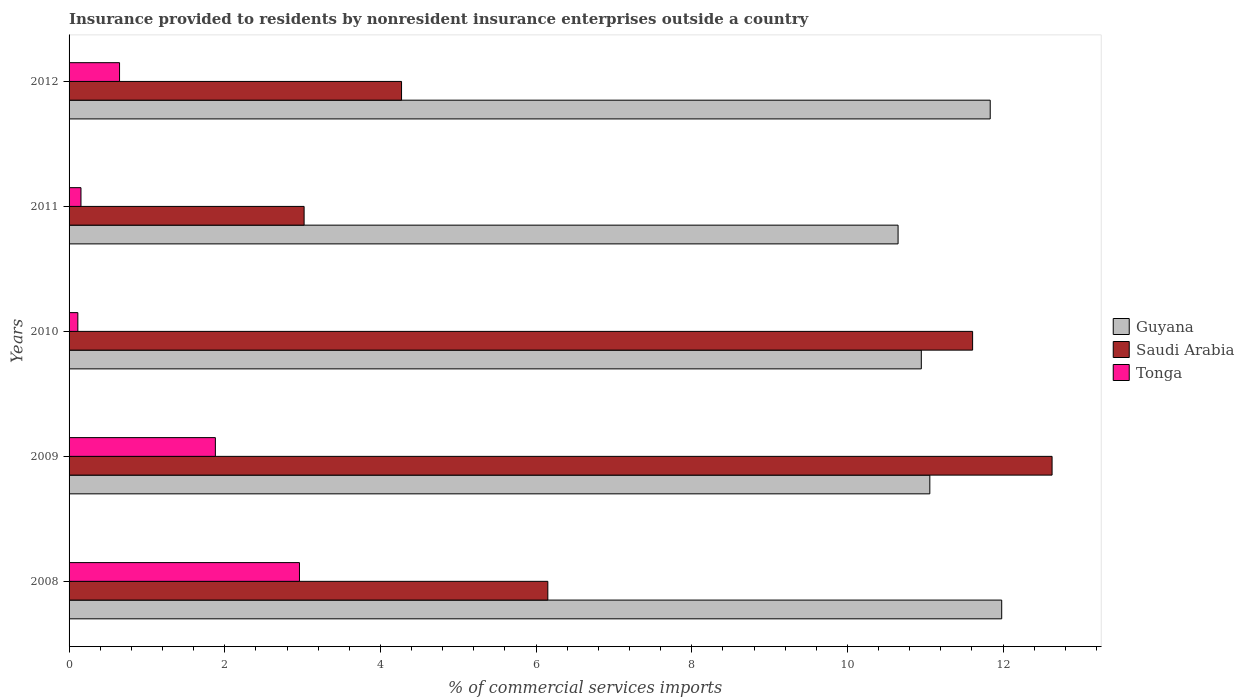How many bars are there on the 4th tick from the top?
Your answer should be very brief. 3. What is the label of the 1st group of bars from the top?
Give a very brief answer. 2012. In how many cases, is the number of bars for a given year not equal to the number of legend labels?
Offer a terse response. 0. What is the Insurance provided to residents in Tonga in 2008?
Make the answer very short. 2.96. Across all years, what is the maximum Insurance provided to residents in Tonga?
Keep it short and to the point. 2.96. Across all years, what is the minimum Insurance provided to residents in Tonga?
Ensure brevity in your answer.  0.11. In which year was the Insurance provided to residents in Saudi Arabia minimum?
Provide a short and direct response. 2011. What is the total Insurance provided to residents in Tonga in the graph?
Give a very brief answer. 5.75. What is the difference between the Insurance provided to residents in Saudi Arabia in 2010 and that in 2011?
Provide a succinct answer. 8.59. What is the difference between the Insurance provided to residents in Tonga in 2010 and the Insurance provided to residents in Saudi Arabia in 2009?
Make the answer very short. -12.52. What is the average Insurance provided to residents in Guyana per year?
Your answer should be very brief. 11.3. In the year 2008, what is the difference between the Insurance provided to residents in Guyana and Insurance provided to residents in Tonga?
Ensure brevity in your answer.  9.02. In how many years, is the Insurance provided to residents in Tonga greater than 10 %?
Offer a very short reply. 0. What is the ratio of the Insurance provided to residents in Saudi Arabia in 2008 to that in 2009?
Provide a succinct answer. 0.49. Is the Insurance provided to residents in Guyana in 2011 less than that in 2012?
Offer a very short reply. Yes. What is the difference between the highest and the second highest Insurance provided to residents in Saudi Arabia?
Ensure brevity in your answer.  1.02. What is the difference between the highest and the lowest Insurance provided to residents in Guyana?
Make the answer very short. 1.33. What does the 3rd bar from the top in 2009 represents?
Your answer should be compact. Guyana. What does the 1st bar from the bottom in 2010 represents?
Your answer should be compact. Guyana. Are all the bars in the graph horizontal?
Ensure brevity in your answer.  Yes. What is the difference between two consecutive major ticks on the X-axis?
Your answer should be very brief. 2. Does the graph contain any zero values?
Offer a very short reply. No. Where does the legend appear in the graph?
Offer a terse response. Center right. How many legend labels are there?
Provide a succinct answer. 3. How are the legend labels stacked?
Offer a very short reply. Vertical. What is the title of the graph?
Your response must be concise. Insurance provided to residents by nonresident insurance enterprises outside a country. What is the label or title of the X-axis?
Ensure brevity in your answer.  % of commercial services imports. What is the % of commercial services imports of Guyana in 2008?
Your answer should be compact. 11.98. What is the % of commercial services imports of Saudi Arabia in 2008?
Make the answer very short. 6.15. What is the % of commercial services imports in Tonga in 2008?
Make the answer very short. 2.96. What is the % of commercial services imports of Guyana in 2009?
Offer a terse response. 11.06. What is the % of commercial services imports of Saudi Arabia in 2009?
Offer a terse response. 12.63. What is the % of commercial services imports in Tonga in 2009?
Ensure brevity in your answer.  1.88. What is the % of commercial services imports in Guyana in 2010?
Offer a terse response. 10.95. What is the % of commercial services imports of Saudi Arabia in 2010?
Ensure brevity in your answer.  11.61. What is the % of commercial services imports in Tonga in 2010?
Your answer should be compact. 0.11. What is the % of commercial services imports in Guyana in 2011?
Provide a short and direct response. 10.65. What is the % of commercial services imports of Saudi Arabia in 2011?
Make the answer very short. 3.02. What is the % of commercial services imports in Tonga in 2011?
Make the answer very short. 0.15. What is the % of commercial services imports of Guyana in 2012?
Your answer should be compact. 11.83. What is the % of commercial services imports in Saudi Arabia in 2012?
Provide a short and direct response. 4.27. What is the % of commercial services imports in Tonga in 2012?
Make the answer very short. 0.65. Across all years, what is the maximum % of commercial services imports of Guyana?
Your answer should be very brief. 11.98. Across all years, what is the maximum % of commercial services imports in Saudi Arabia?
Your answer should be very brief. 12.63. Across all years, what is the maximum % of commercial services imports in Tonga?
Offer a terse response. 2.96. Across all years, what is the minimum % of commercial services imports in Guyana?
Provide a short and direct response. 10.65. Across all years, what is the minimum % of commercial services imports of Saudi Arabia?
Provide a succinct answer. 3.02. Across all years, what is the minimum % of commercial services imports in Tonga?
Your response must be concise. 0.11. What is the total % of commercial services imports in Guyana in the graph?
Your answer should be very brief. 56.48. What is the total % of commercial services imports of Saudi Arabia in the graph?
Keep it short and to the point. 37.68. What is the total % of commercial services imports of Tonga in the graph?
Make the answer very short. 5.75. What is the difference between the % of commercial services imports of Guyana in 2008 and that in 2009?
Ensure brevity in your answer.  0.92. What is the difference between the % of commercial services imports of Saudi Arabia in 2008 and that in 2009?
Keep it short and to the point. -6.48. What is the difference between the % of commercial services imports of Tonga in 2008 and that in 2009?
Give a very brief answer. 1.08. What is the difference between the % of commercial services imports of Guyana in 2008 and that in 2010?
Your response must be concise. 1.03. What is the difference between the % of commercial services imports of Saudi Arabia in 2008 and that in 2010?
Give a very brief answer. -5.46. What is the difference between the % of commercial services imports of Tonga in 2008 and that in 2010?
Keep it short and to the point. 2.85. What is the difference between the % of commercial services imports of Guyana in 2008 and that in 2011?
Your response must be concise. 1.33. What is the difference between the % of commercial services imports in Saudi Arabia in 2008 and that in 2011?
Your response must be concise. 3.13. What is the difference between the % of commercial services imports of Tonga in 2008 and that in 2011?
Keep it short and to the point. 2.81. What is the difference between the % of commercial services imports in Guyana in 2008 and that in 2012?
Provide a short and direct response. 0.15. What is the difference between the % of commercial services imports in Saudi Arabia in 2008 and that in 2012?
Your answer should be compact. 1.88. What is the difference between the % of commercial services imports in Tonga in 2008 and that in 2012?
Keep it short and to the point. 2.31. What is the difference between the % of commercial services imports of Guyana in 2009 and that in 2010?
Your answer should be compact. 0.11. What is the difference between the % of commercial services imports in Saudi Arabia in 2009 and that in 2010?
Keep it short and to the point. 1.02. What is the difference between the % of commercial services imports of Tonga in 2009 and that in 2010?
Provide a succinct answer. 1.77. What is the difference between the % of commercial services imports in Guyana in 2009 and that in 2011?
Make the answer very short. 0.41. What is the difference between the % of commercial services imports of Saudi Arabia in 2009 and that in 2011?
Your answer should be very brief. 9.61. What is the difference between the % of commercial services imports in Tonga in 2009 and that in 2011?
Provide a succinct answer. 1.73. What is the difference between the % of commercial services imports in Guyana in 2009 and that in 2012?
Offer a very short reply. -0.78. What is the difference between the % of commercial services imports in Saudi Arabia in 2009 and that in 2012?
Your answer should be very brief. 8.36. What is the difference between the % of commercial services imports of Tonga in 2009 and that in 2012?
Provide a short and direct response. 1.23. What is the difference between the % of commercial services imports of Guyana in 2010 and that in 2011?
Offer a very short reply. 0.3. What is the difference between the % of commercial services imports of Saudi Arabia in 2010 and that in 2011?
Provide a succinct answer. 8.59. What is the difference between the % of commercial services imports of Tonga in 2010 and that in 2011?
Give a very brief answer. -0.04. What is the difference between the % of commercial services imports of Guyana in 2010 and that in 2012?
Your response must be concise. -0.89. What is the difference between the % of commercial services imports of Saudi Arabia in 2010 and that in 2012?
Give a very brief answer. 7.34. What is the difference between the % of commercial services imports in Tonga in 2010 and that in 2012?
Your answer should be very brief. -0.54. What is the difference between the % of commercial services imports in Guyana in 2011 and that in 2012?
Offer a very short reply. -1.18. What is the difference between the % of commercial services imports in Saudi Arabia in 2011 and that in 2012?
Your response must be concise. -1.25. What is the difference between the % of commercial services imports in Tonga in 2011 and that in 2012?
Provide a short and direct response. -0.5. What is the difference between the % of commercial services imports of Guyana in 2008 and the % of commercial services imports of Saudi Arabia in 2009?
Your answer should be compact. -0.65. What is the difference between the % of commercial services imports of Guyana in 2008 and the % of commercial services imports of Tonga in 2009?
Offer a terse response. 10.1. What is the difference between the % of commercial services imports in Saudi Arabia in 2008 and the % of commercial services imports in Tonga in 2009?
Offer a very short reply. 4.27. What is the difference between the % of commercial services imports in Guyana in 2008 and the % of commercial services imports in Saudi Arabia in 2010?
Offer a terse response. 0.37. What is the difference between the % of commercial services imports of Guyana in 2008 and the % of commercial services imports of Tonga in 2010?
Provide a succinct answer. 11.87. What is the difference between the % of commercial services imports of Saudi Arabia in 2008 and the % of commercial services imports of Tonga in 2010?
Provide a short and direct response. 6.04. What is the difference between the % of commercial services imports of Guyana in 2008 and the % of commercial services imports of Saudi Arabia in 2011?
Provide a succinct answer. 8.96. What is the difference between the % of commercial services imports of Guyana in 2008 and the % of commercial services imports of Tonga in 2011?
Provide a short and direct response. 11.83. What is the difference between the % of commercial services imports of Saudi Arabia in 2008 and the % of commercial services imports of Tonga in 2011?
Your answer should be very brief. 6. What is the difference between the % of commercial services imports of Guyana in 2008 and the % of commercial services imports of Saudi Arabia in 2012?
Give a very brief answer. 7.71. What is the difference between the % of commercial services imports in Guyana in 2008 and the % of commercial services imports in Tonga in 2012?
Your answer should be very brief. 11.33. What is the difference between the % of commercial services imports of Saudi Arabia in 2008 and the % of commercial services imports of Tonga in 2012?
Ensure brevity in your answer.  5.5. What is the difference between the % of commercial services imports in Guyana in 2009 and the % of commercial services imports in Saudi Arabia in 2010?
Make the answer very short. -0.55. What is the difference between the % of commercial services imports in Guyana in 2009 and the % of commercial services imports in Tonga in 2010?
Your response must be concise. 10.95. What is the difference between the % of commercial services imports in Saudi Arabia in 2009 and the % of commercial services imports in Tonga in 2010?
Ensure brevity in your answer.  12.52. What is the difference between the % of commercial services imports in Guyana in 2009 and the % of commercial services imports in Saudi Arabia in 2011?
Your answer should be very brief. 8.04. What is the difference between the % of commercial services imports of Guyana in 2009 and the % of commercial services imports of Tonga in 2011?
Provide a short and direct response. 10.91. What is the difference between the % of commercial services imports in Saudi Arabia in 2009 and the % of commercial services imports in Tonga in 2011?
Ensure brevity in your answer.  12.48. What is the difference between the % of commercial services imports in Guyana in 2009 and the % of commercial services imports in Saudi Arabia in 2012?
Your answer should be compact. 6.79. What is the difference between the % of commercial services imports of Guyana in 2009 and the % of commercial services imports of Tonga in 2012?
Keep it short and to the point. 10.41. What is the difference between the % of commercial services imports in Saudi Arabia in 2009 and the % of commercial services imports in Tonga in 2012?
Provide a short and direct response. 11.98. What is the difference between the % of commercial services imports of Guyana in 2010 and the % of commercial services imports of Saudi Arabia in 2011?
Your answer should be very brief. 7.93. What is the difference between the % of commercial services imports of Guyana in 2010 and the % of commercial services imports of Tonga in 2011?
Your response must be concise. 10.8. What is the difference between the % of commercial services imports of Saudi Arabia in 2010 and the % of commercial services imports of Tonga in 2011?
Offer a terse response. 11.46. What is the difference between the % of commercial services imports of Guyana in 2010 and the % of commercial services imports of Saudi Arabia in 2012?
Your response must be concise. 6.68. What is the difference between the % of commercial services imports in Guyana in 2010 and the % of commercial services imports in Tonga in 2012?
Your answer should be very brief. 10.3. What is the difference between the % of commercial services imports of Saudi Arabia in 2010 and the % of commercial services imports of Tonga in 2012?
Keep it short and to the point. 10.96. What is the difference between the % of commercial services imports of Guyana in 2011 and the % of commercial services imports of Saudi Arabia in 2012?
Provide a succinct answer. 6.38. What is the difference between the % of commercial services imports in Guyana in 2011 and the % of commercial services imports in Tonga in 2012?
Provide a short and direct response. 10. What is the difference between the % of commercial services imports in Saudi Arabia in 2011 and the % of commercial services imports in Tonga in 2012?
Give a very brief answer. 2.37. What is the average % of commercial services imports in Guyana per year?
Provide a short and direct response. 11.3. What is the average % of commercial services imports of Saudi Arabia per year?
Keep it short and to the point. 7.54. What is the average % of commercial services imports of Tonga per year?
Your answer should be very brief. 1.15. In the year 2008, what is the difference between the % of commercial services imports of Guyana and % of commercial services imports of Saudi Arabia?
Your answer should be very brief. 5.83. In the year 2008, what is the difference between the % of commercial services imports of Guyana and % of commercial services imports of Tonga?
Provide a succinct answer. 9.02. In the year 2008, what is the difference between the % of commercial services imports in Saudi Arabia and % of commercial services imports in Tonga?
Provide a short and direct response. 3.19. In the year 2009, what is the difference between the % of commercial services imports of Guyana and % of commercial services imports of Saudi Arabia?
Keep it short and to the point. -1.57. In the year 2009, what is the difference between the % of commercial services imports of Guyana and % of commercial services imports of Tonga?
Your answer should be very brief. 9.18. In the year 2009, what is the difference between the % of commercial services imports in Saudi Arabia and % of commercial services imports in Tonga?
Your answer should be compact. 10.75. In the year 2010, what is the difference between the % of commercial services imports in Guyana and % of commercial services imports in Saudi Arabia?
Provide a short and direct response. -0.66. In the year 2010, what is the difference between the % of commercial services imports in Guyana and % of commercial services imports in Tonga?
Ensure brevity in your answer.  10.84. In the year 2010, what is the difference between the % of commercial services imports in Saudi Arabia and % of commercial services imports in Tonga?
Offer a very short reply. 11.5. In the year 2011, what is the difference between the % of commercial services imports of Guyana and % of commercial services imports of Saudi Arabia?
Give a very brief answer. 7.63. In the year 2011, what is the difference between the % of commercial services imports in Guyana and % of commercial services imports in Tonga?
Give a very brief answer. 10.5. In the year 2011, what is the difference between the % of commercial services imports of Saudi Arabia and % of commercial services imports of Tonga?
Ensure brevity in your answer.  2.87. In the year 2012, what is the difference between the % of commercial services imports of Guyana and % of commercial services imports of Saudi Arabia?
Give a very brief answer. 7.56. In the year 2012, what is the difference between the % of commercial services imports in Guyana and % of commercial services imports in Tonga?
Your answer should be compact. 11.19. In the year 2012, what is the difference between the % of commercial services imports of Saudi Arabia and % of commercial services imports of Tonga?
Your answer should be very brief. 3.62. What is the ratio of the % of commercial services imports of Guyana in 2008 to that in 2009?
Keep it short and to the point. 1.08. What is the ratio of the % of commercial services imports of Saudi Arabia in 2008 to that in 2009?
Provide a short and direct response. 0.49. What is the ratio of the % of commercial services imports in Tonga in 2008 to that in 2009?
Your answer should be compact. 1.57. What is the ratio of the % of commercial services imports of Guyana in 2008 to that in 2010?
Ensure brevity in your answer.  1.09. What is the ratio of the % of commercial services imports in Saudi Arabia in 2008 to that in 2010?
Give a very brief answer. 0.53. What is the ratio of the % of commercial services imports in Tonga in 2008 to that in 2010?
Your response must be concise. 26.28. What is the ratio of the % of commercial services imports of Saudi Arabia in 2008 to that in 2011?
Ensure brevity in your answer.  2.04. What is the ratio of the % of commercial services imports of Tonga in 2008 to that in 2011?
Provide a short and direct response. 19.37. What is the ratio of the % of commercial services imports in Guyana in 2008 to that in 2012?
Ensure brevity in your answer.  1.01. What is the ratio of the % of commercial services imports of Saudi Arabia in 2008 to that in 2012?
Your response must be concise. 1.44. What is the ratio of the % of commercial services imports of Tonga in 2008 to that in 2012?
Your answer should be compact. 4.56. What is the ratio of the % of commercial services imports of Saudi Arabia in 2009 to that in 2010?
Offer a terse response. 1.09. What is the ratio of the % of commercial services imports of Tonga in 2009 to that in 2010?
Provide a short and direct response. 16.69. What is the ratio of the % of commercial services imports of Guyana in 2009 to that in 2011?
Make the answer very short. 1.04. What is the ratio of the % of commercial services imports of Saudi Arabia in 2009 to that in 2011?
Make the answer very short. 4.18. What is the ratio of the % of commercial services imports of Tonga in 2009 to that in 2011?
Your response must be concise. 12.3. What is the ratio of the % of commercial services imports of Guyana in 2009 to that in 2012?
Ensure brevity in your answer.  0.93. What is the ratio of the % of commercial services imports of Saudi Arabia in 2009 to that in 2012?
Offer a terse response. 2.96. What is the ratio of the % of commercial services imports in Tonga in 2009 to that in 2012?
Keep it short and to the point. 2.9. What is the ratio of the % of commercial services imports of Guyana in 2010 to that in 2011?
Your response must be concise. 1.03. What is the ratio of the % of commercial services imports in Saudi Arabia in 2010 to that in 2011?
Make the answer very short. 3.84. What is the ratio of the % of commercial services imports of Tonga in 2010 to that in 2011?
Give a very brief answer. 0.74. What is the ratio of the % of commercial services imports of Guyana in 2010 to that in 2012?
Provide a succinct answer. 0.93. What is the ratio of the % of commercial services imports in Saudi Arabia in 2010 to that in 2012?
Provide a short and direct response. 2.72. What is the ratio of the % of commercial services imports in Tonga in 2010 to that in 2012?
Your response must be concise. 0.17. What is the ratio of the % of commercial services imports in Guyana in 2011 to that in 2012?
Offer a terse response. 0.9. What is the ratio of the % of commercial services imports in Saudi Arabia in 2011 to that in 2012?
Make the answer very short. 0.71. What is the ratio of the % of commercial services imports in Tonga in 2011 to that in 2012?
Your answer should be very brief. 0.24. What is the difference between the highest and the second highest % of commercial services imports in Guyana?
Keep it short and to the point. 0.15. What is the difference between the highest and the second highest % of commercial services imports in Saudi Arabia?
Keep it short and to the point. 1.02. What is the difference between the highest and the second highest % of commercial services imports of Tonga?
Make the answer very short. 1.08. What is the difference between the highest and the lowest % of commercial services imports in Guyana?
Provide a succinct answer. 1.33. What is the difference between the highest and the lowest % of commercial services imports of Saudi Arabia?
Make the answer very short. 9.61. What is the difference between the highest and the lowest % of commercial services imports of Tonga?
Provide a short and direct response. 2.85. 